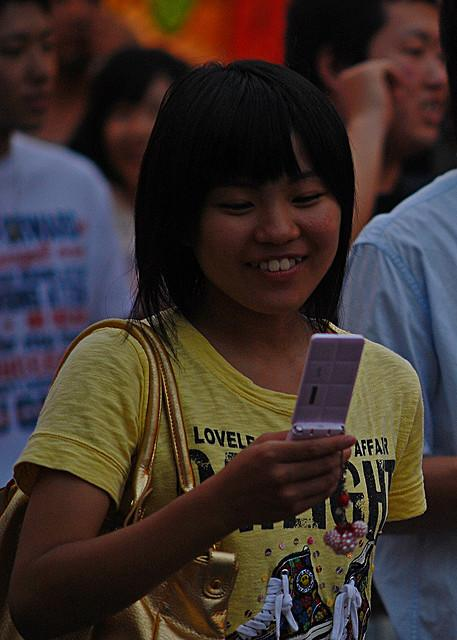What is there a picture of on the yellow shirt?

Choices:
A) elves
B) swords
C) cows
D) shoes shoes 